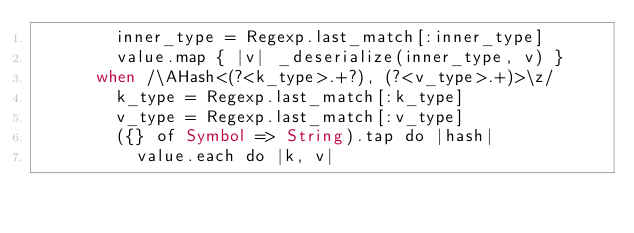<code> <loc_0><loc_0><loc_500><loc_500><_Crystal_>        inner_type = Regexp.last_match[:inner_type]
        value.map { |v| _deserialize(inner_type, v) }
      when /\AHash<(?<k_type>.+?), (?<v_type>.+)>\z/
        k_type = Regexp.last_match[:k_type]
        v_type = Regexp.last_match[:v_type]
        ({} of Symbol => String).tap do |hash|
          value.each do |k, v|</code> 